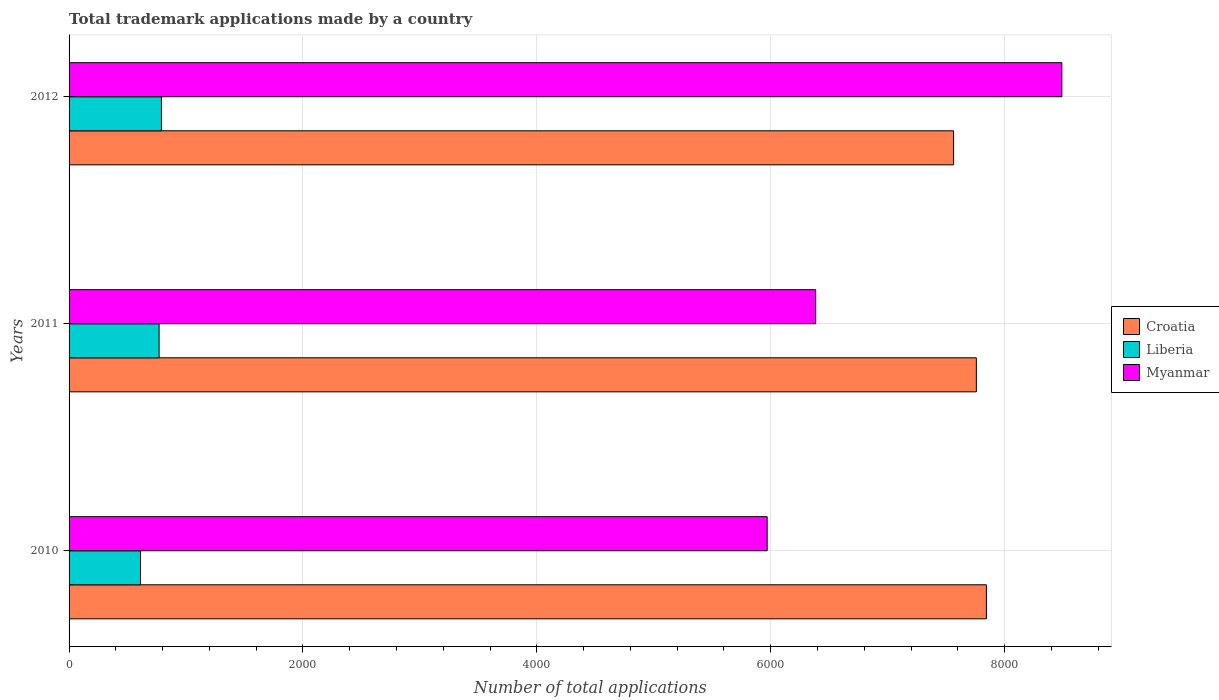Are the number of bars per tick equal to the number of legend labels?
Ensure brevity in your answer.  Yes. Are the number of bars on each tick of the Y-axis equal?
Your answer should be compact. Yes. How many bars are there on the 2nd tick from the top?
Provide a succinct answer. 3. How many bars are there on the 3rd tick from the bottom?
Give a very brief answer. 3. What is the label of the 1st group of bars from the top?
Provide a short and direct response. 2012. What is the number of applications made by in Croatia in 2011?
Your response must be concise. 7759. Across all years, what is the maximum number of applications made by in Liberia?
Keep it short and to the point. 790. Across all years, what is the minimum number of applications made by in Croatia?
Provide a short and direct response. 7564. In which year was the number of applications made by in Croatia maximum?
Provide a succinct answer. 2010. In which year was the number of applications made by in Croatia minimum?
Provide a succinct answer. 2012. What is the total number of applications made by in Liberia in the graph?
Give a very brief answer. 2171. What is the difference between the number of applications made by in Liberia in 2010 and that in 2012?
Provide a short and direct response. -179. What is the difference between the number of applications made by in Croatia in 2010 and the number of applications made by in Myanmar in 2012?
Make the answer very short. -645. What is the average number of applications made by in Liberia per year?
Provide a short and direct response. 723.67. In the year 2010, what is the difference between the number of applications made by in Liberia and number of applications made by in Croatia?
Your response must be concise. -7234. In how many years, is the number of applications made by in Liberia greater than 800 ?
Provide a short and direct response. 0. What is the ratio of the number of applications made by in Croatia in 2011 to that in 2012?
Offer a very short reply. 1.03. Is the number of applications made by in Liberia in 2010 less than that in 2011?
Keep it short and to the point. Yes. Is the difference between the number of applications made by in Liberia in 2010 and 2011 greater than the difference between the number of applications made by in Croatia in 2010 and 2011?
Keep it short and to the point. No. What is the difference between the highest and the lowest number of applications made by in Myanmar?
Keep it short and to the point. 2520. What does the 1st bar from the top in 2011 represents?
Offer a very short reply. Myanmar. What does the 3rd bar from the bottom in 2011 represents?
Keep it short and to the point. Myanmar. Is it the case that in every year, the sum of the number of applications made by in Myanmar and number of applications made by in Croatia is greater than the number of applications made by in Liberia?
Offer a very short reply. Yes. How many bars are there?
Offer a terse response. 9. Are all the bars in the graph horizontal?
Offer a very short reply. Yes. What is the difference between two consecutive major ticks on the X-axis?
Your response must be concise. 2000. Are the values on the major ticks of X-axis written in scientific E-notation?
Your answer should be compact. No. Does the graph contain any zero values?
Ensure brevity in your answer.  No. Does the graph contain grids?
Your response must be concise. Yes. How many legend labels are there?
Make the answer very short. 3. How are the legend labels stacked?
Ensure brevity in your answer.  Vertical. What is the title of the graph?
Make the answer very short. Total trademark applications made by a country. Does "Ghana" appear as one of the legend labels in the graph?
Offer a terse response. No. What is the label or title of the X-axis?
Give a very brief answer. Number of total applications. What is the Number of total applications in Croatia in 2010?
Offer a very short reply. 7845. What is the Number of total applications of Liberia in 2010?
Keep it short and to the point. 611. What is the Number of total applications in Myanmar in 2010?
Offer a very short reply. 5970. What is the Number of total applications of Croatia in 2011?
Provide a short and direct response. 7759. What is the Number of total applications of Liberia in 2011?
Your answer should be compact. 770. What is the Number of total applications in Myanmar in 2011?
Offer a terse response. 6385. What is the Number of total applications of Croatia in 2012?
Your response must be concise. 7564. What is the Number of total applications of Liberia in 2012?
Make the answer very short. 790. What is the Number of total applications of Myanmar in 2012?
Offer a terse response. 8490. Across all years, what is the maximum Number of total applications of Croatia?
Provide a succinct answer. 7845. Across all years, what is the maximum Number of total applications in Liberia?
Keep it short and to the point. 790. Across all years, what is the maximum Number of total applications of Myanmar?
Make the answer very short. 8490. Across all years, what is the minimum Number of total applications of Croatia?
Your answer should be compact. 7564. Across all years, what is the minimum Number of total applications of Liberia?
Your answer should be very brief. 611. Across all years, what is the minimum Number of total applications in Myanmar?
Your response must be concise. 5970. What is the total Number of total applications in Croatia in the graph?
Your answer should be compact. 2.32e+04. What is the total Number of total applications of Liberia in the graph?
Give a very brief answer. 2171. What is the total Number of total applications in Myanmar in the graph?
Make the answer very short. 2.08e+04. What is the difference between the Number of total applications of Croatia in 2010 and that in 2011?
Your answer should be compact. 86. What is the difference between the Number of total applications in Liberia in 2010 and that in 2011?
Keep it short and to the point. -159. What is the difference between the Number of total applications in Myanmar in 2010 and that in 2011?
Offer a very short reply. -415. What is the difference between the Number of total applications in Croatia in 2010 and that in 2012?
Your response must be concise. 281. What is the difference between the Number of total applications in Liberia in 2010 and that in 2012?
Keep it short and to the point. -179. What is the difference between the Number of total applications of Myanmar in 2010 and that in 2012?
Your answer should be very brief. -2520. What is the difference between the Number of total applications in Croatia in 2011 and that in 2012?
Offer a very short reply. 195. What is the difference between the Number of total applications in Myanmar in 2011 and that in 2012?
Your answer should be very brief. -2105. What is the difference between the Number of total applications in Croatia in 2010 and the Number of total applications in Liberia in 2011?
Give a very brief answer. 7075. What is the difference between the Number of total applications in Croatia in 2010 and the Number of total applications in Myanmar in 2011?
Your response must be concise. 1460. What is the difference between the Number of total applications in Liberia in 2010 and the Number of total applications in Myanmar in 2011?
Give a very brief answer. -5774. What is the difference between the Number of total applications of Croatia in 2010 and the Number of total applications of Liberia in 2012?
Your answer should be compact. 7055. What is the difference between the Number of total applications in Croatia in 2010 and the Number of total applications in Myanmar in 2012?
Offer a terse response. -645. What is the difference between the Number of total applications of Liberia in 2010 and the Number of total applications of Myanmar in 2012?
Your answer should be very brief. -7879. What is the difference between the Number of total applications in Croatia in 2011 and the Number of total applications in Liberia in 2012?
Provide a short and direct response. 6969. What is the difference between the Number of total applications in Croatia in 2011 and the Number of total applications in Myanmar in 2012?
Your answer should be compact. -731. What is the difference between the Number of total applications of Liberia in 2011 and the Number of total applications of Myanmar in 2012?
Keep it short and to the point. -7720. What is the average Number of total applications of Croatia per year?
Offer a very short reply. 7722.67. What is the average Number of total applications of Liberia per year?
Offer a terse response. 723.67. What is the average Number of total applications of Myanmar per year?
Offer a terse response. 6948.33. In the year 2010, what is the difference between the Number of total applications in Croatia and Number of total applications in Liberia?
Offer a terse response. 7234. In the year 2010, what is the difference between the Number of total applications in Croatia and Number of total applications in Myanmar?
Your response must be concise. 1875. In the year 2010, what is the difference between the Number of total applications of Liberia and Number of total applications of Myanmar?
Offer a terse response. -5359. In the year 2011, what is the difference between the Number of total applications in Croatia and Number of total applications in Liberia?
Your answer should be compact. 6989. In the year 2011, what is the difference between the Number of total applications in Croatia and Number of total applications in Myanmar?
Provide a succinct answer. 1374. In the year 2011, what is the difference between the Number of total applications of Liberia and Number of total applications of Myanmar?
Your response must be concise. -5615. In the year 2012, what is the difference between the Number of total applications of Croatia and Number of total applications of Liberia?
Ensure brevity in your answer.  6774. In the year 2012, what is the difference between the Number of total applications in Croatia and Number of total applications in Myanmar?
Give a very brief answer. -926. In the year 2012, what is the difference between the Number of total applications in Liberia and Number of total applications in Myanmar?
Make the answer very short. -7700. What is the ratio of the Number of total applications in Croatia in 2010 to that in 2011?
Provide a succinct answer. 1.01. What is the ratio of the Number of total applications in Liberia in 2010 to that in 2011?
Your answer should be very brief. 0.79. What is the ratio of the Number of total applications in Myanmar in 2010 to that in 2011?
Provide a succinct answer. 0.94. What is the ratio of the Number of total applications of Croatia in 2010 to that in 2012?
Keep it short and to the point. 1.04. What is the ratio of the Number of total applications of Liberia in 2010 to that in 2012?
Your response must be concise. 0.77. What is the ratio of the Number of total applications of Myanmar in 2010 to that in 2012?
Your response must be concise. 0.7. What is the ratio of the Number of total applications in Croatia in 2011 to that in 2012?
Your answer should be very brief. 1.03. What is the ratio of the Number of total applications of Liberia in 2011 to that in 2012?
Make the answer very short. 0.97. What is the ratio of the Number of total applications in Myanmar in 2011 to that in 2012?
Your answer should be compact. 0.75. What is the difference between the highest and the second highest Number of total applications of Liberia?
Your response must be concise. 20. What is the difference between the highest and the second highest Number of total applications in Myanmar?
Provide a short and direct response. 2105. What is the difference between the highest and the lowest Number of total applications of Croatia?
Your answer should be very brief. 281. What is the difference between the highest and the lowest Number of total applications in Liberia?
Keep it short and to the point. 179. What is the difference between the highest and the lowest Number of total applications in Myanmar?
Make the answer very short. 2520. 